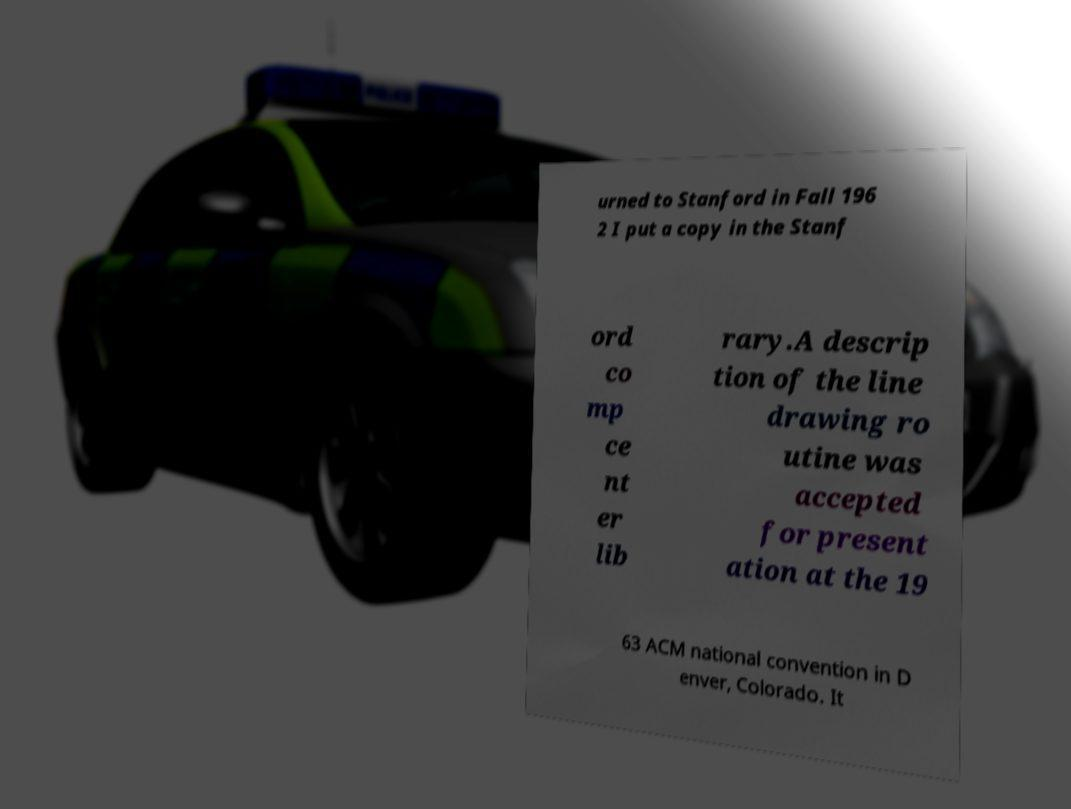For documentation purposes, I need the text within this image transcribed. Could you provide that? urned to Stanford in Fall 196 2 I put a copy in the Stanf ord co mp ce nt er lib rary.A descrip tion of the line drawing ro utine was accepted for present ation at the 19 63 ACM national convention in D enver, Colorado. It 